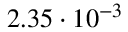<formula> <loc_0><loc_0><loc_500><loc_500>2 . 3 5 \cdot 1 0 ^ { - 3 }</formula> 